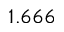Convert formula to latex. <formula><loc_0><loc_0><loc_500><loc_500>1 . 6 6 6</formula> 